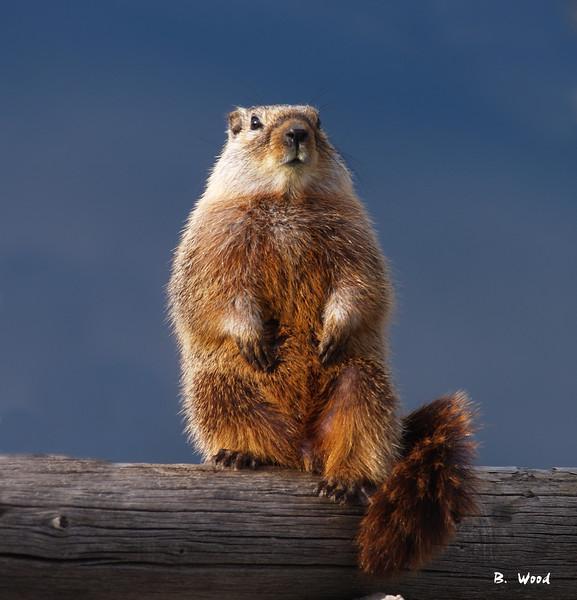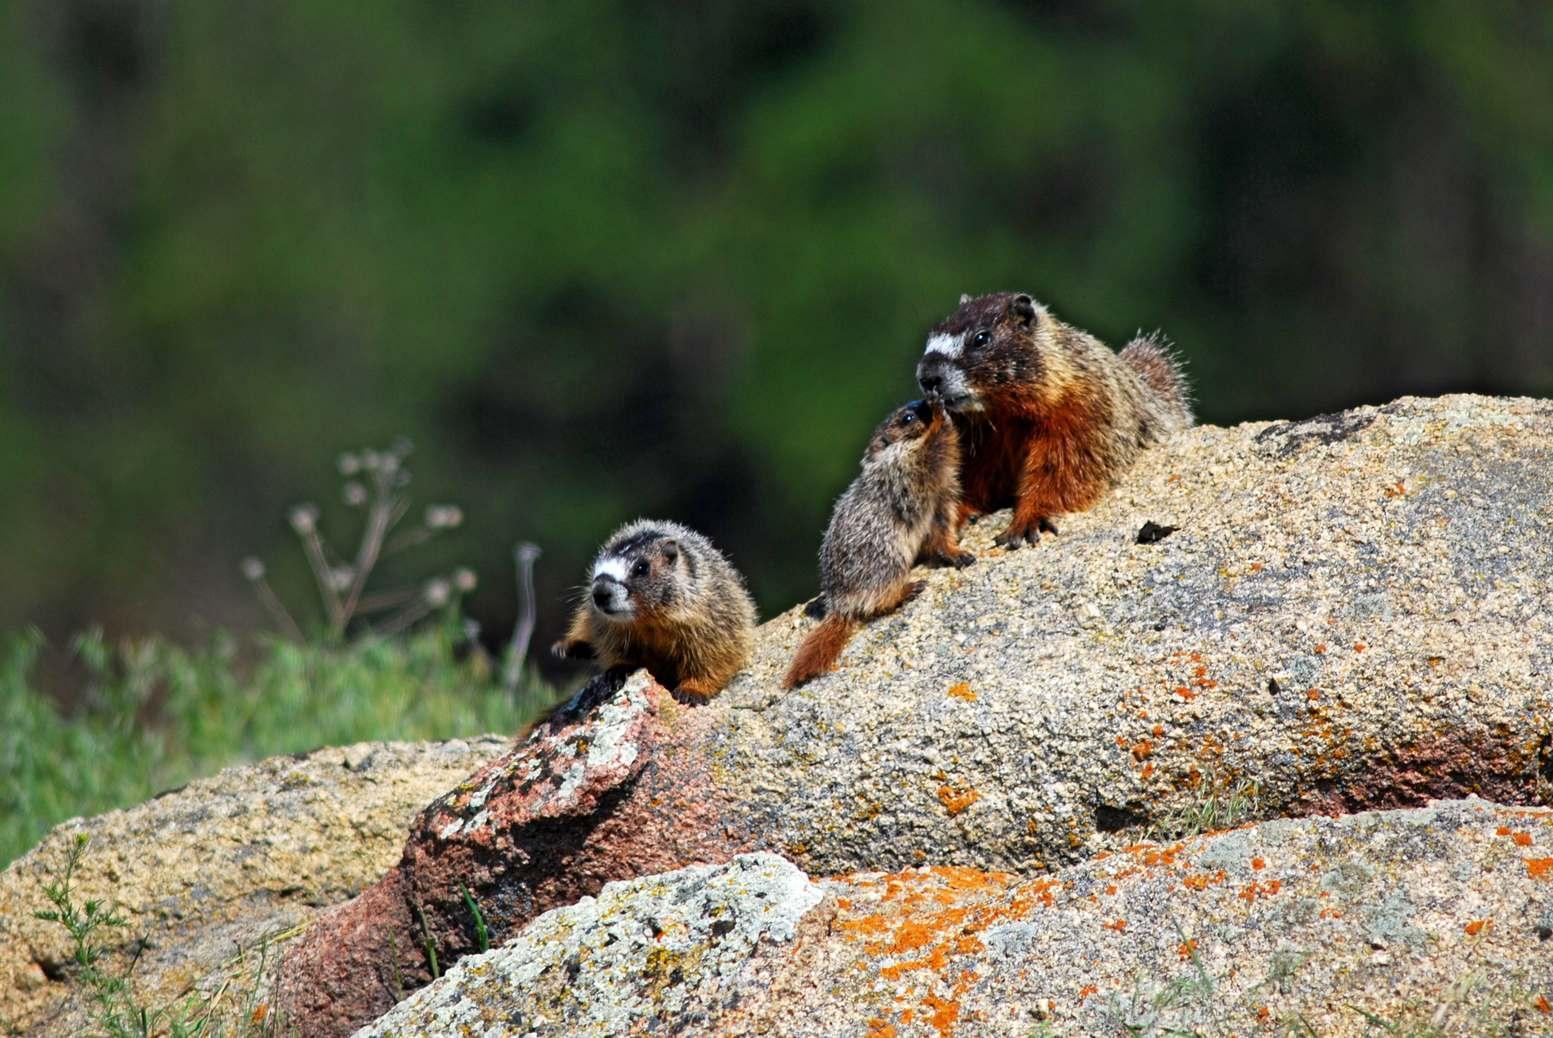The first image is the image on the left, the second image is the image on the right. Given the left and right images, does the statement "The left and right image contains the same number of prairie dogs." hold true? Answer yes or no. No. The first image is the image on the left, the second image is the image on the right. Analyze the images presented: Is the assertion "There is at least two rodents in the right image." valid? Answer yes or no. Yes. 